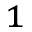Convert formula to latex. <formula><loc_0><loc_0><loc_500><loc_500>^ { 1 }</formula> 